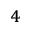<formula> <loc_0><loc_0><loc_500><loc_500>_ { 4 }</formula> 